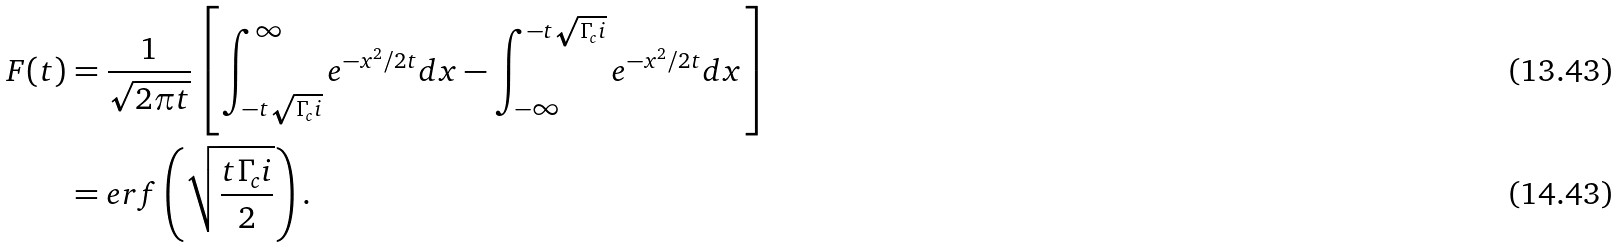<formula> <loc_0><loc_0><loc_500><loc_500>F ( t ) & = \frac { 1 } { \sqrt { 2 \pi t } } \left [ \int _ { - t \sqrt { \Gamma _ { c } i } } ^ { \infty } e ^ { - x ^ { 2 } / 2 t } d x - \int _ { - \infty } ^ { - t \sqrt { \Gamma _ { c } i } } e ^ { - x ^ { 2 } / 2 t } d x \right ] \\ & = e r f \left ( \sqrt { \frac { t \Gamma _ { c } i } { 2 } } \right ) .</formula> 